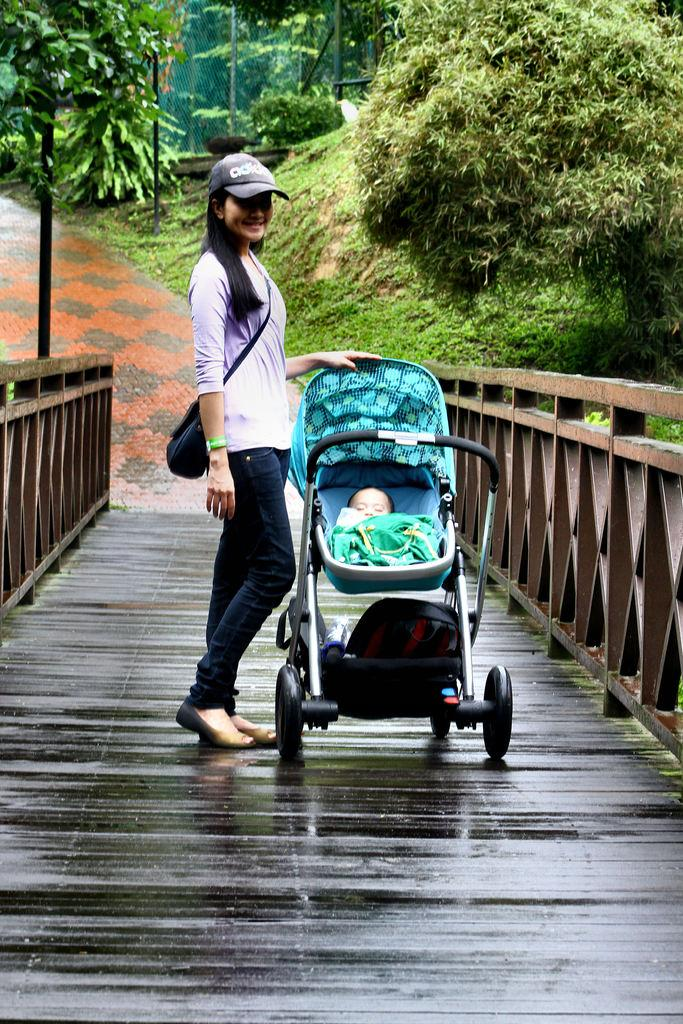What is the baby in the image being carried in? The baby in the image is in a carrier. Who is standing on the deck in the image? There is a woman standing on the deck in the image. What type of fence is visible in the image? There is a wooden fence in the image. What type of vegetation is visible in the image? Grass is visible in the image. What type of surface is visible in the image? There is a pathway in the image. What type of structure is visible in the image? There are poles in the image. What type of natural feature is visible in the image? There is a group of trees in the image. Where is the baby's grandfather in the image? There is no mention of a grandfather in the image, so we cannot determine his location. What type of vase is visible on the deck in the image? There is no vase present in the image. 